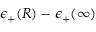<formula> <loc_0><loc_0><loc_500><loc_500>\epsilon _ { + } ( R ) - \epsilon _ { + } ( \infty )</formula> 